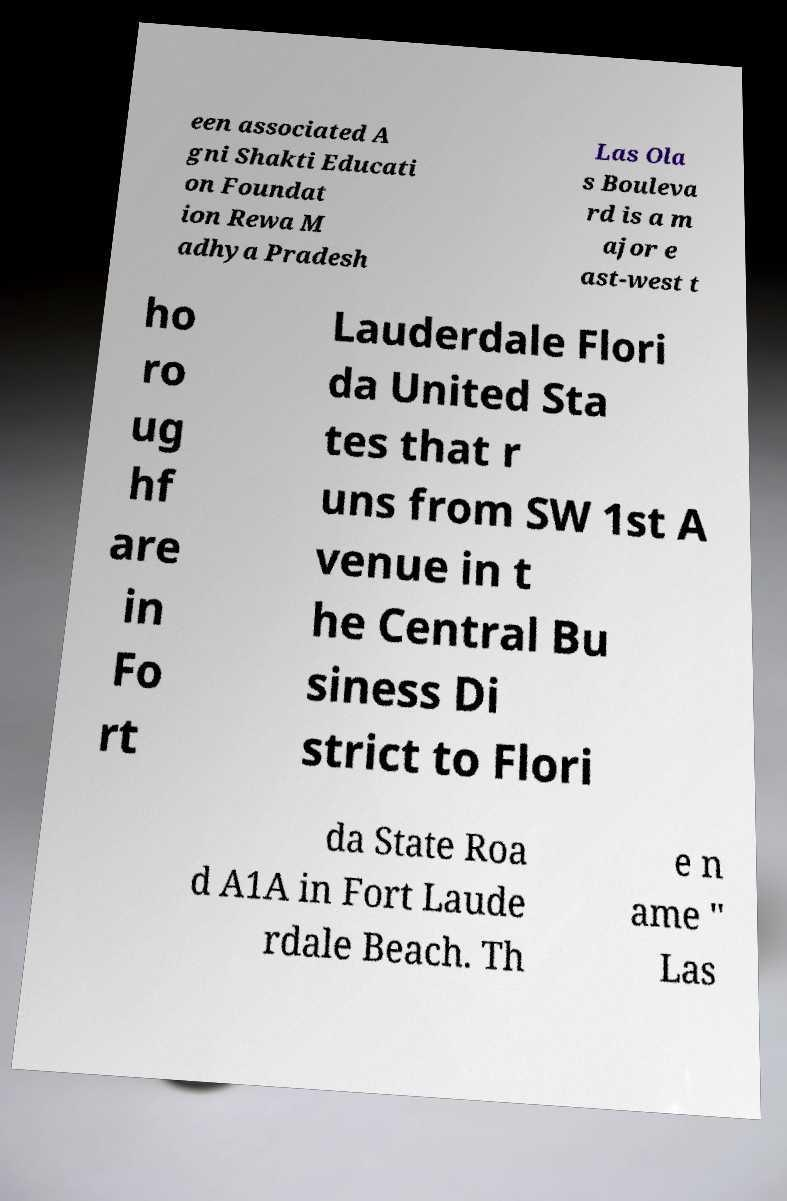There's text embedded in this image that I need extracted. Can you transcribe it verbatim? een associated A gni Shakti Educati on Foundat ion Rewa M adhya Pradesh Las Ola s Bouleva rd is a m ajor e ast-west t ho ro ug hf are in Fo rt Lauderdale Flori da United Sta tes that r uns from SW 1st A venue in t he Central Bu siness Di strict to Flori da State Roa d A1A in Fort Laude rdale Beach. Th e n ame " Las 